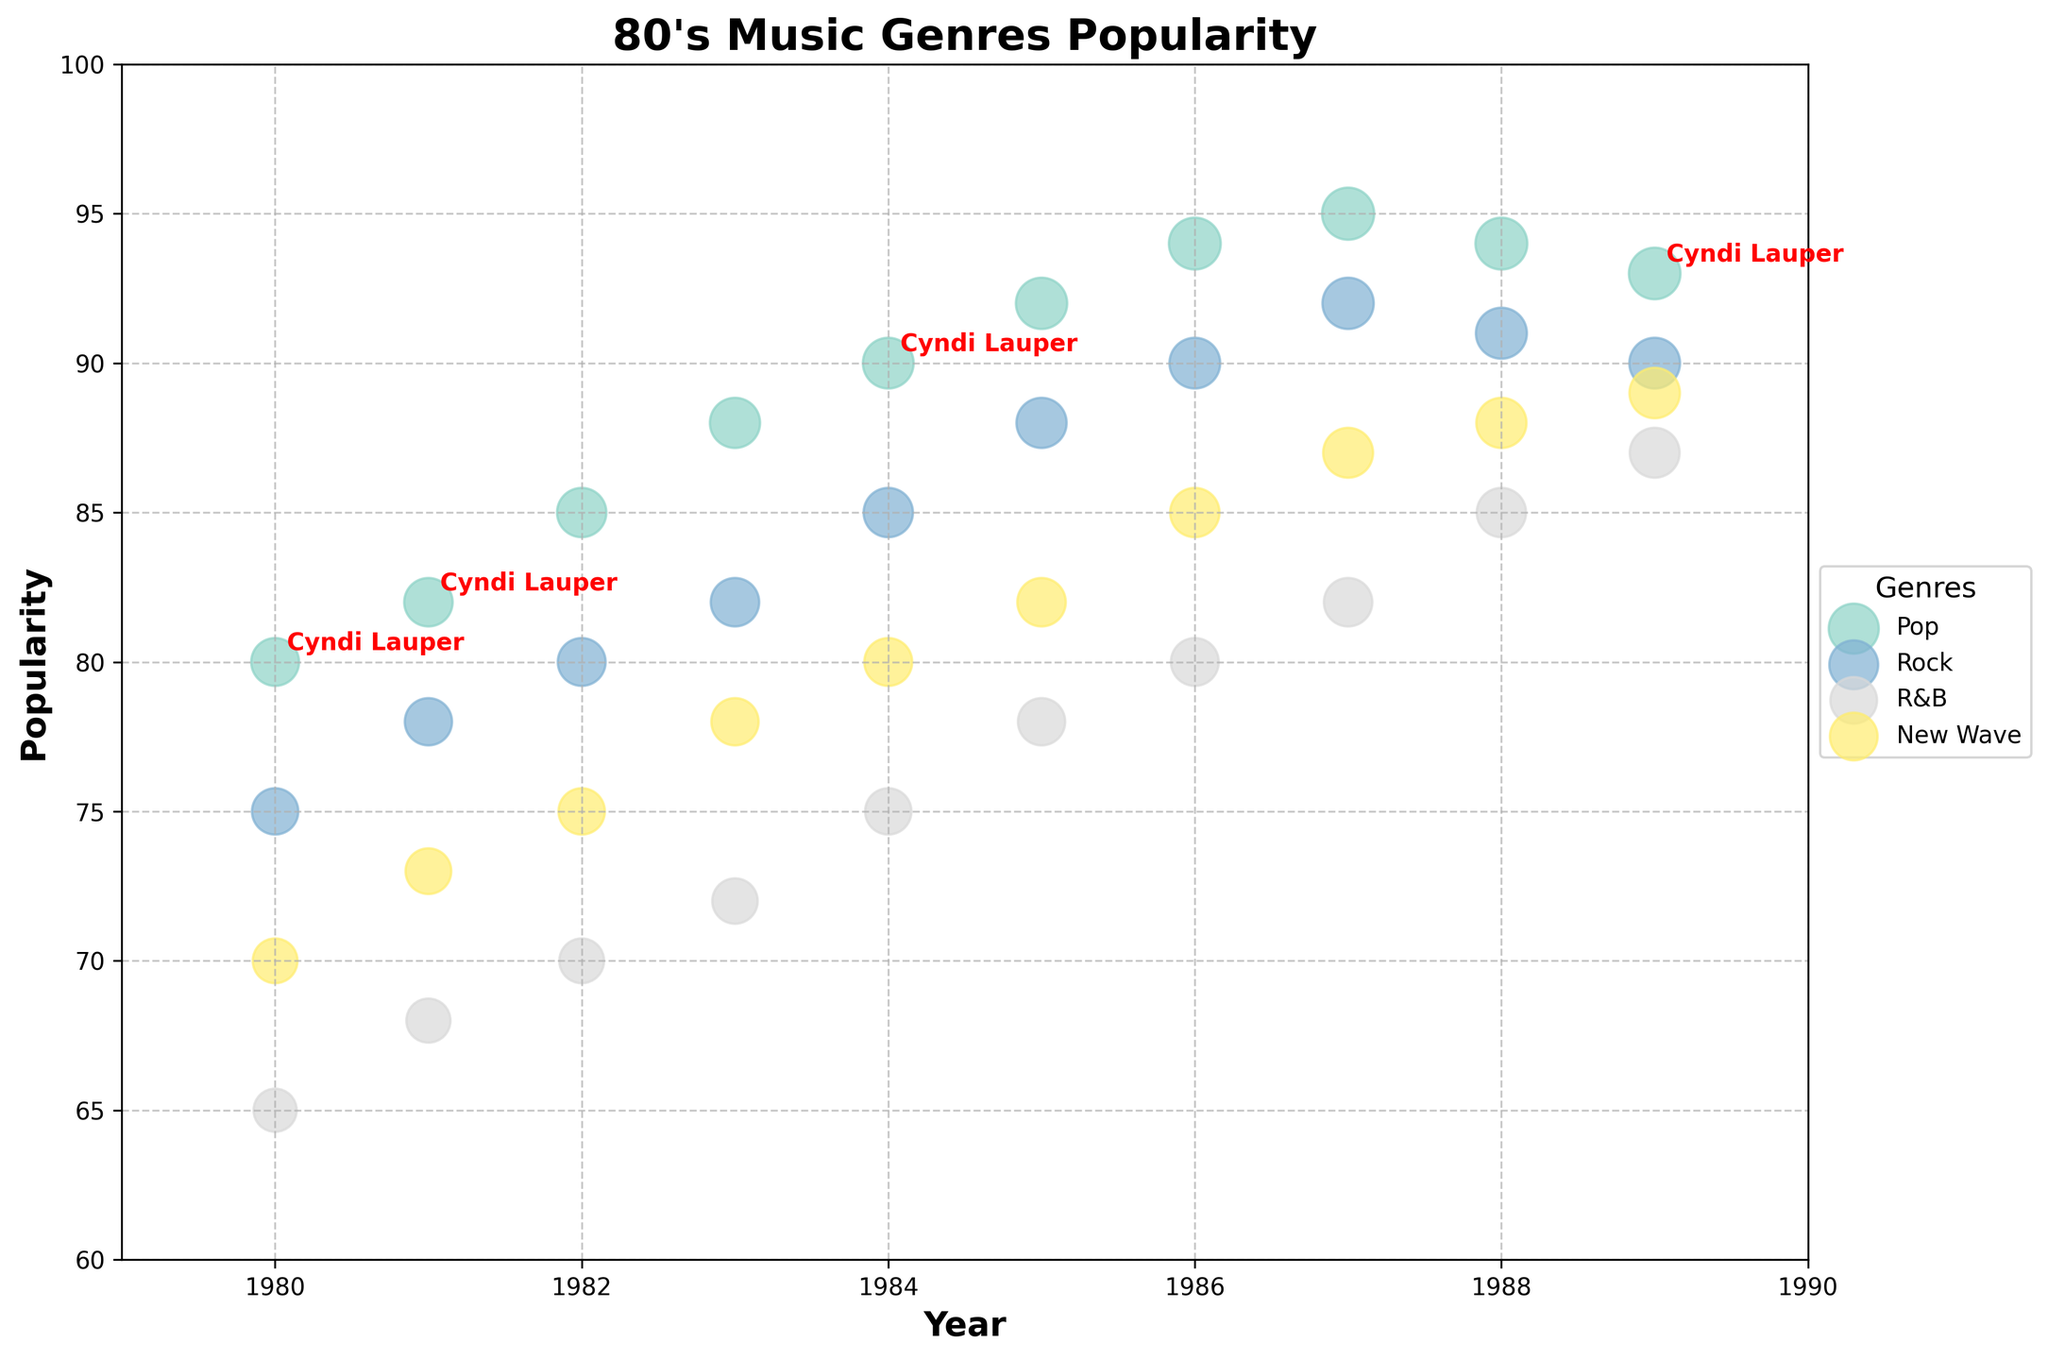What is the title of the figure? The title is prominently displayed at the top of the figure. It reads "80's Music Genres Popularity".
Answer: 80's Music Genres Popularity Which genre has the highest popularity in 1987? Check the data points for 1987 and look for the genre with the highest y-value. "Pop" with a popularity of 95.
Answer: Pop How many genres are represented in the figure? Count the unique genres listed in the legend on the right side of the figure. There are Pop, Rock, R&B, and New Wave.
Answer: 4 Which year shows the highest popularity for Cyndi Lauper? Look for the annotations with "Cyndi Lauper" and check their corresponding y-values. The highest popularity for Cyndi Lauper is in 1984 with a value of 90.
Answer: 1984 What is the difference in popularity between Pop and Rock in 1986? Identify the popularity of Pop and Rock in 1986: Pop (94) and Rock (90). Then calculate the difference: 94 - 90 = 4.
Answer: 4 Which genre shows the highest increase in popularity from 1980 to 1989? Examine the popularity of each genre in 1980 and 1989. Calculate the increase: Pop (93-80), Rock (90-75), R&B (87-65), New Wave (89-70). New Wave shows the highest increase.
Answer: New Wave How many bubbles in total are plotted for the Rock genre? Count the data points labeled "Rock" and represented as bubbles for each year on the figure. There is one bubble for each year from 1980 to 1989, totaling 10 bubbles.
Answer: 10 Which artist is annotated in red and bold? Check the annotations to find the artist name that is in red and bold. It corresponds to "Cyndi Lauper".
Answer: Cyndi Lauper What is the average popularity of Pop music from 1980 to 1989? Sum the popularity values for Pop in each year and divide by the number of years: (80+82+85+88+90+92+94+95+94+93)/10 = 87.8
Answer: 87.8 Which genre had the lowest popularity in 1983? Evaluate each genre's popularity in 1983 and identify the lowest value: Pop (88), Rock (82), R&B (72), New Wave (78). The lowest is R&B with 72.
Answer: R&B 